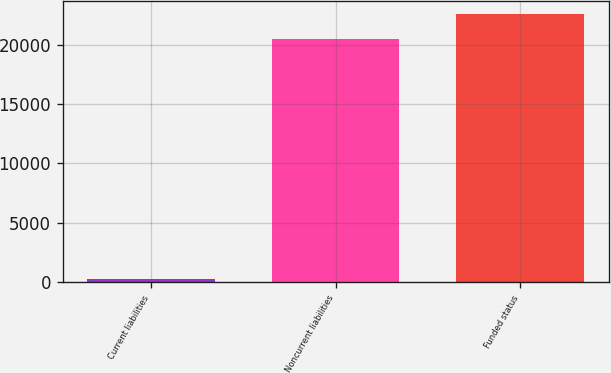<chart> <loc_0><loc_0><loc_500><loc_500><bar_chart><fcel>Current liabilities<fcel>Noncurrent liabilities<fcel>Funded status<nl><fcel>260<fcel>20508<fcel>22558.8<nl></chart> 